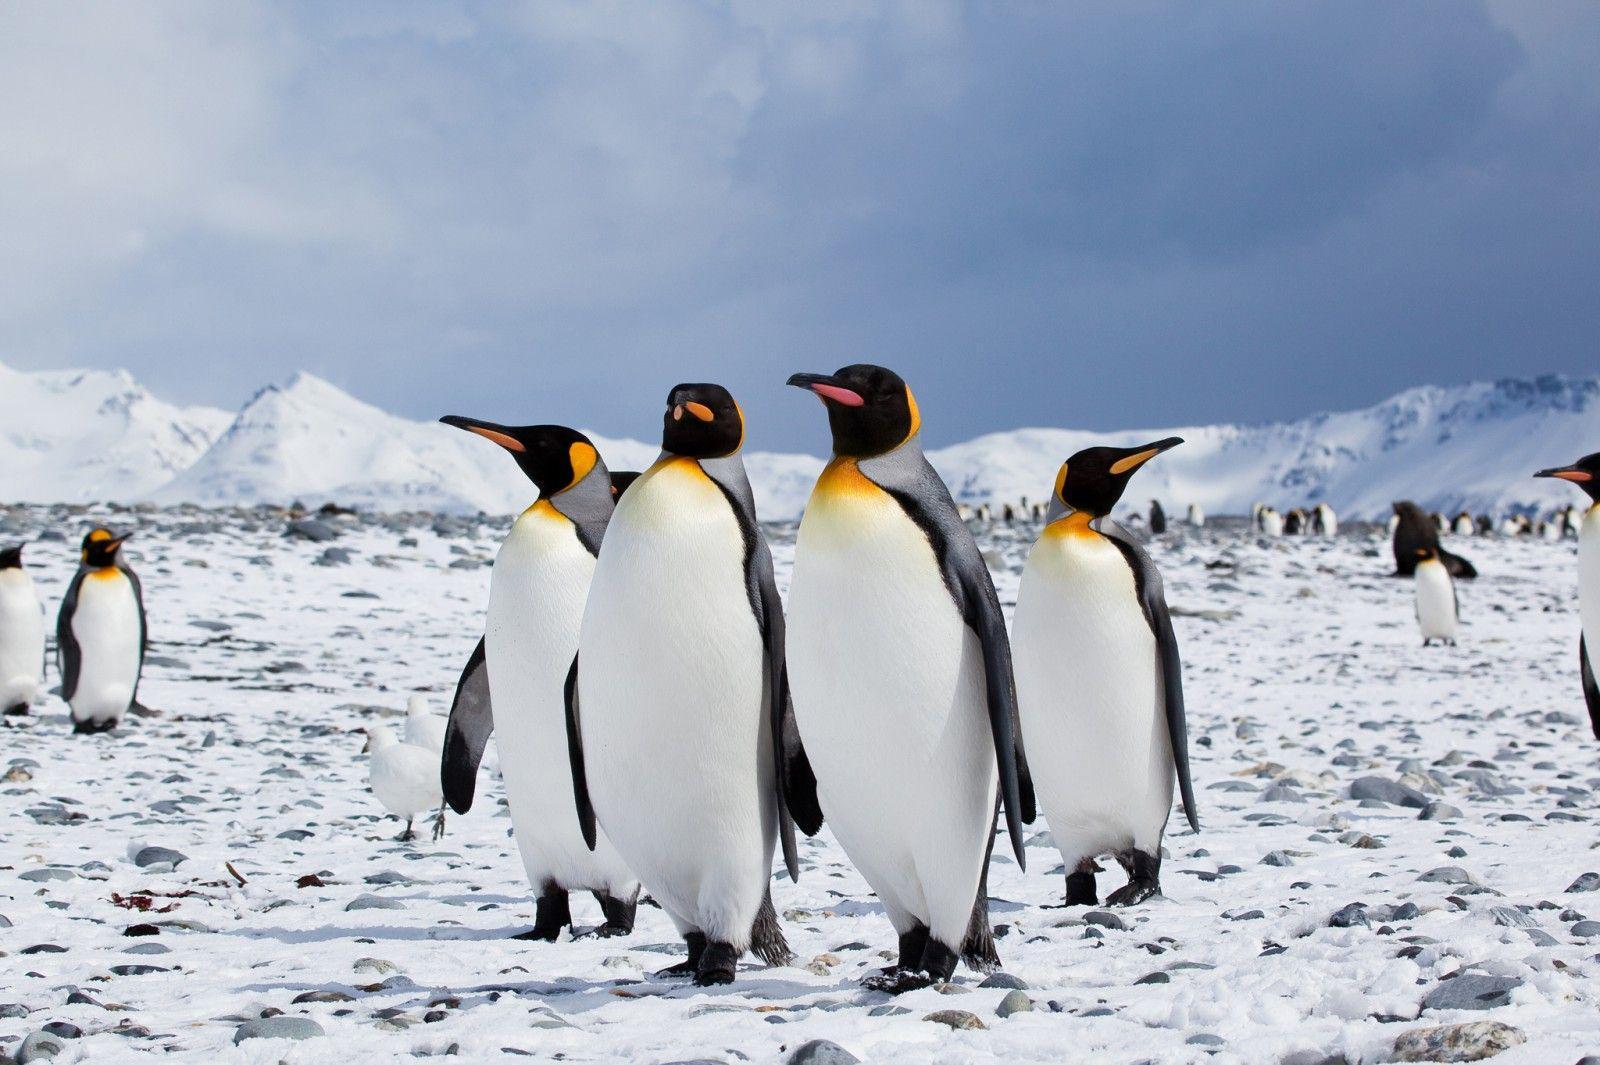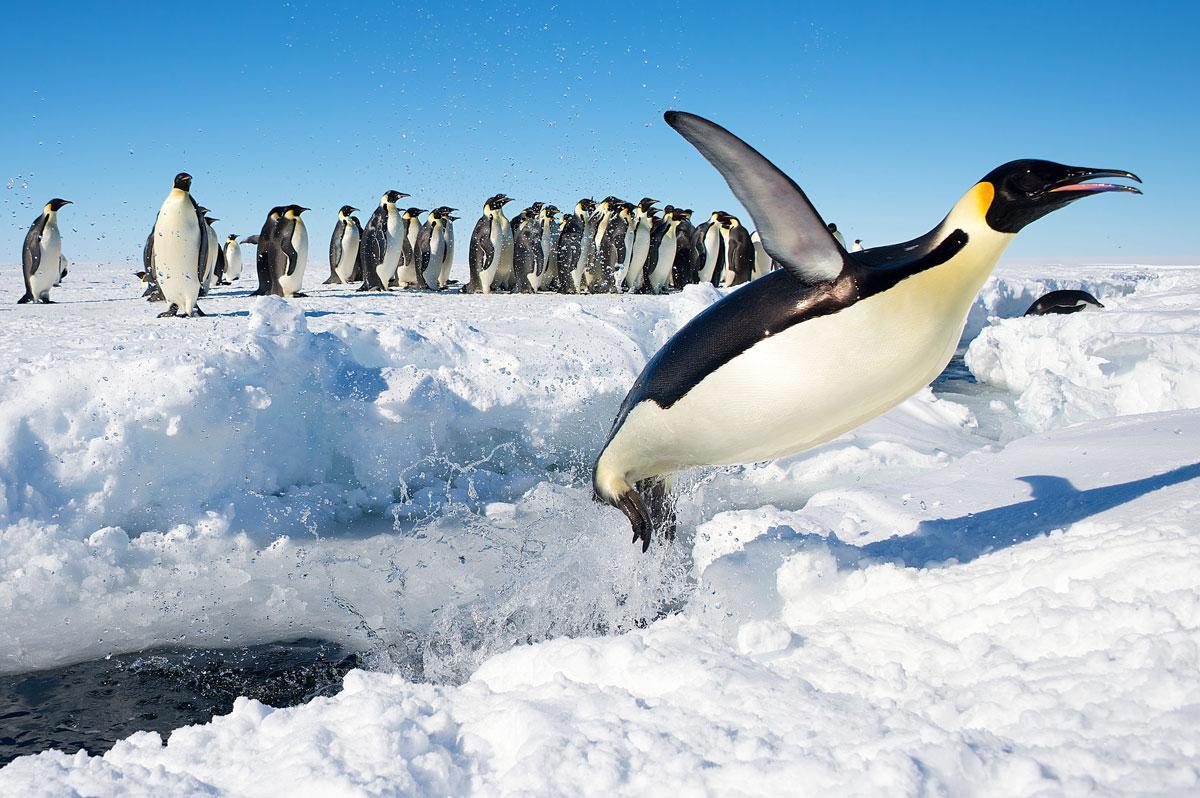The first image is the image on the left, the second image is the image on the right. For the images displayed, is the sentence "There is exactly one animal in the image on the left." factually correct? Answer yes or no. No. The first image is the image on the left, the second image is the image on the right. Analyze the images presented: Is the assertion "At least one of the images show only one penguin." valid? Answer yes or no. No. 